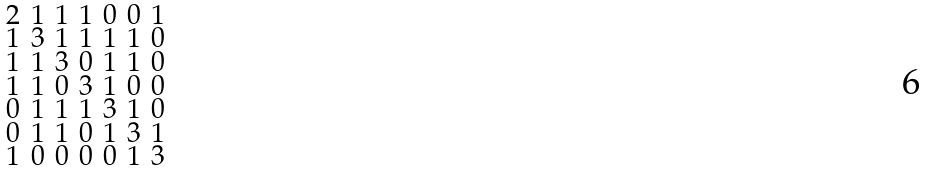<formula> <loc_0><loc_0><loc_500><loc_500>\begin{smallmatrix} 2 & 1 & 1 & 1 & 0 & 0 & 1 \\ 1 & 3 & 1 & 1 & 1 & 1 & 0 \\ 1 & 1 & 3 & 0 & 1 & 1 & 0 \\ 1 & 1 & 0 & 3 & 1 & 0 & 0 \\ 0 & 1 & 1 & 1 & 3 & 1 & 0 \\ 0 & 1 & 1 & 0 & 1 & 3 & 1 \\ 1 & 0 & 0 & 0 & 0 & 1 & 3 \end{smallmatrix}</formula> 